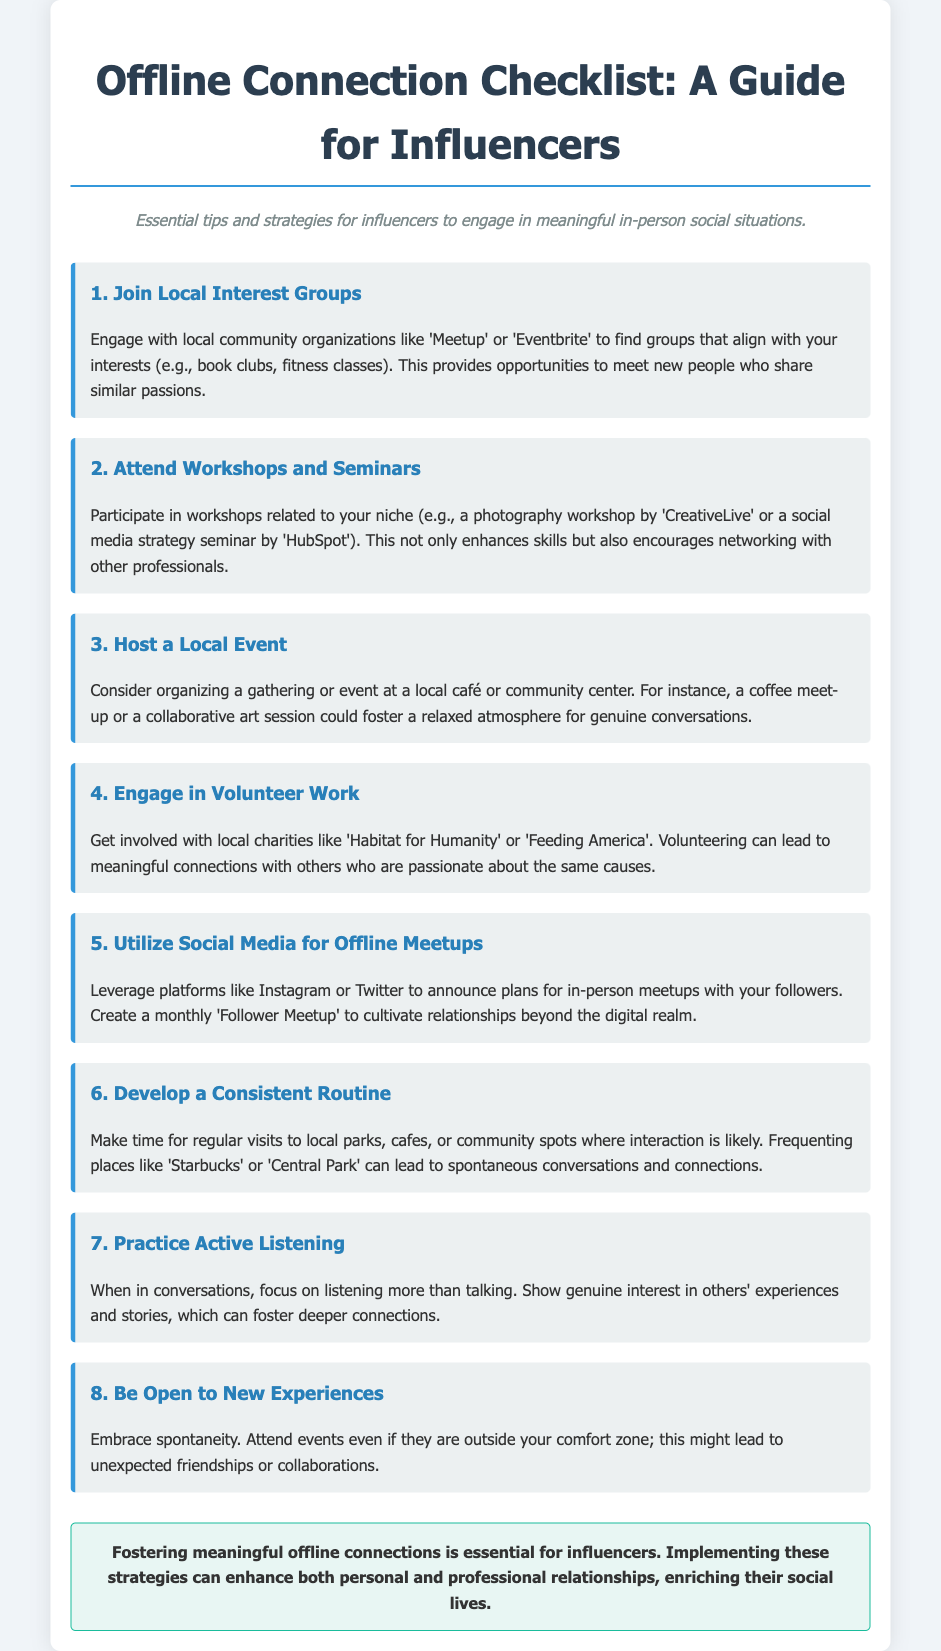What is the title of the document? The title is stated at the top of the document and serves as the main header.
Answer: Offline Connection Checklist: A Guide for Influencers What is one platform suggested for event finding? This information can be found in the first tip section of the document.
Answer: Meetup How many tips are provided in the checklist? The number of tips can be counted from the listed sections in the document.
Answer: 8 Which activity is suggested to develop face-to-face connections? This activity is mentioned in multiple sections of the document.
Answer: Volunteer work What is a recommended strategy for hosting followers? The document mentions a specific plan for enhancing follower engagement.
Answer: Follower Meetup Which skill is emphasized in the seventh tip? This specific skill is highlighted as important for connection in conversations.
Answer: Active Listening What should influencers do to embrace spontaneity? This suggestion is included in the eighth tip of the document.
Answer: Attend events outside comfort zone Where is the conclusion located in the document? The conclusion summarizes the main purpose and can be found at a specific location.
Answer: At the bottom of the document 